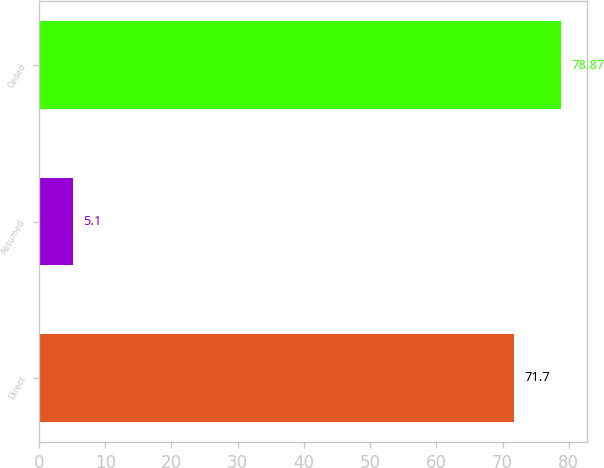Convert chart. <chart><loc_0><loc_0><loc_500><loc_500><bar_chart><fcel>Direct<fcel>Assumed<fcel>Ceded<nl><fcel>71.7<fcel>5.1<fcel>78.87<nl></chart> 